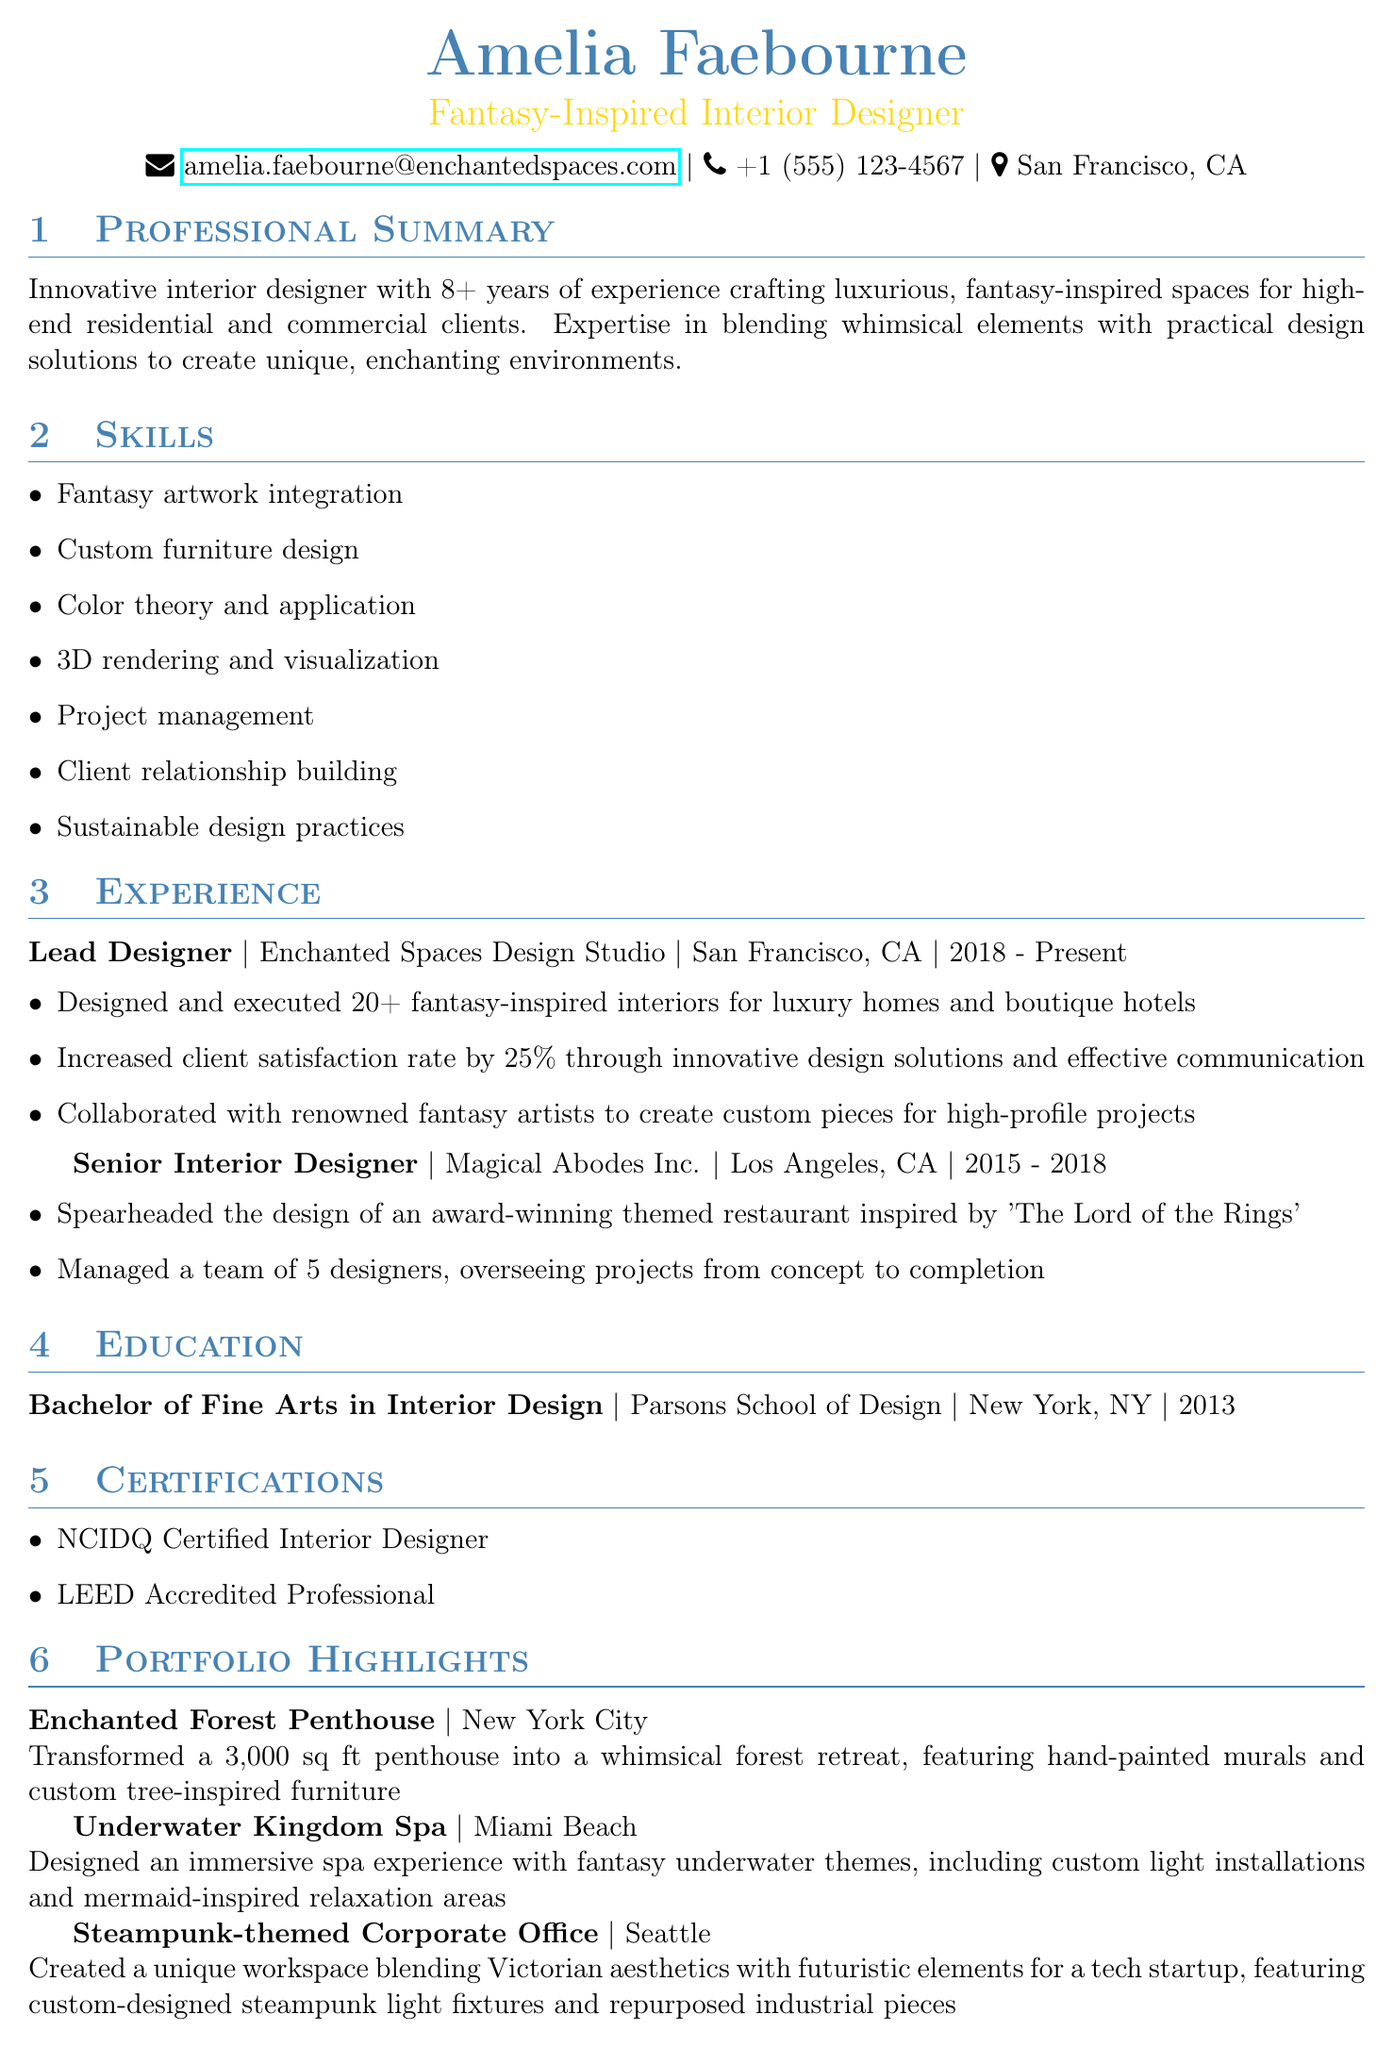What is the name of the designer? The name of the designer is at the top of the document in the personal info section.
Answer: Amelia Faebourne How many years of experience does the designer have? The professional summary section states the number of years of experience.
Answer: 8+ What type of degree does Amelia hold? The education section specifies the degree obtained by Amelia.
Answer: Bachelor of Fine Arts in Interior Design What is the name of the studio where Amelia currently works? The experience section mentions the current employer of Amelia.
Answer: Enchanted Spaces Design Studio How many fantasy-inspired interiors did Amelia design at her current job? The achievements under experience detail the number of interiors designed at the current job.
Answer: 20+ Which city houses the project "Underwater Kingdom Spa"? The portfolio highlights list the location of the project.
Answer: Miami Beach What certification does Amelia have that relates to sustainable design? The certifications section lists Amelia's professional certifications.
Answer: LEED Accredited Professional What was the theme of the restaurant designed by Amelia at her previous job? The experience section highlights a specific theme of a project worked on by Amelia.
Answer: The Lord of the Rings How many designers did Amelia manage in her previous role? The experience section provides the number of designers managed.
Answer: 5 